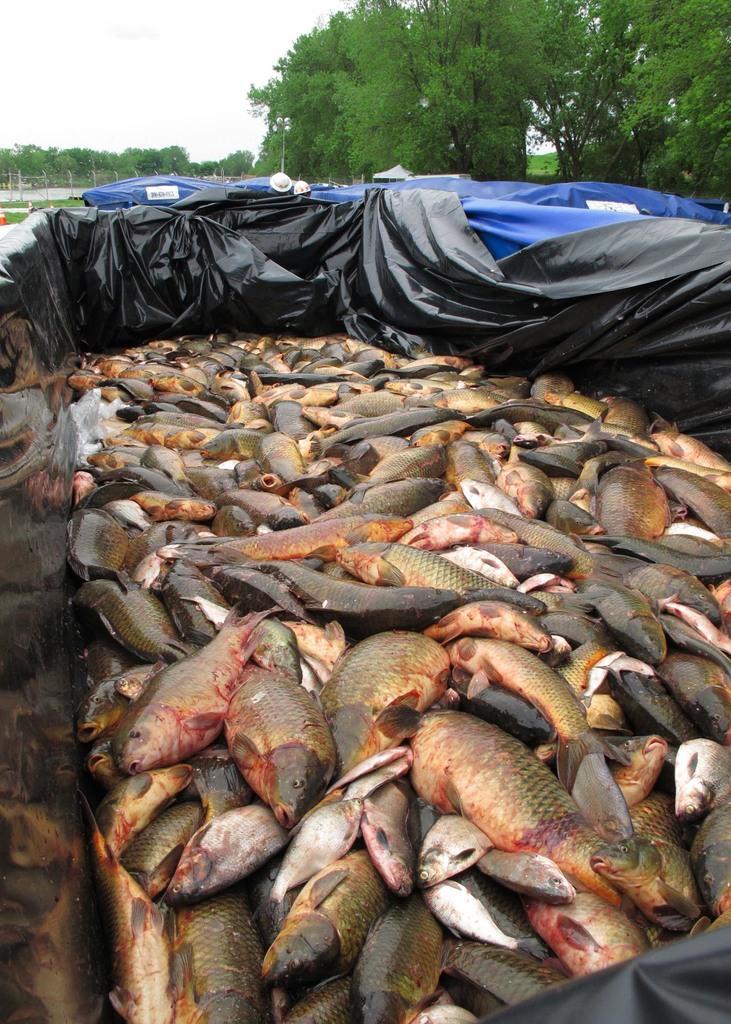In one or two sentences, can you explain what this image depicts? In the center of the image there are fishes in a black color cover. In the background of the image there are trees and sky. 